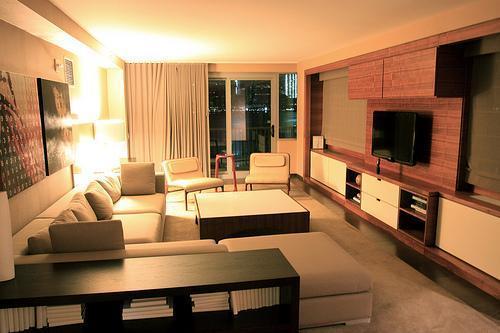How many chairs are visible?
Give a very brief answer. 2. How many walls are visible?
Give a very brief answer. 3. 